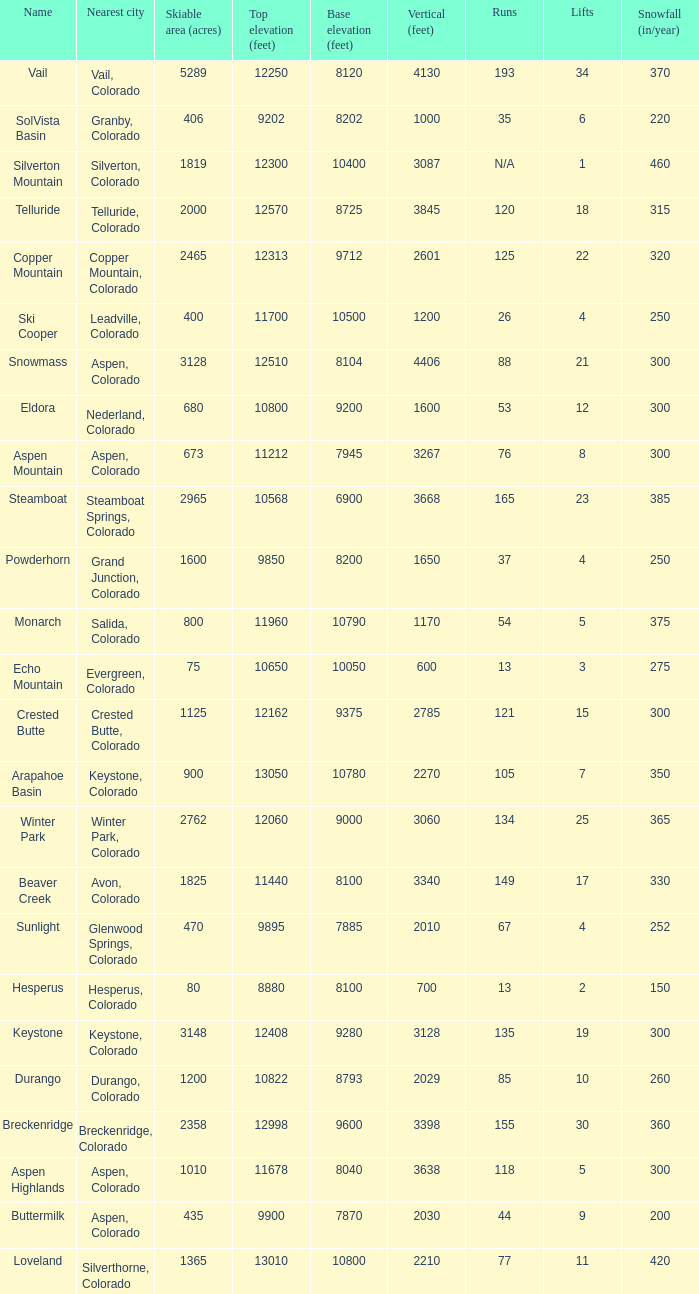If there are 30 lifts, what is the name of the ski resort? Breckenridge. 